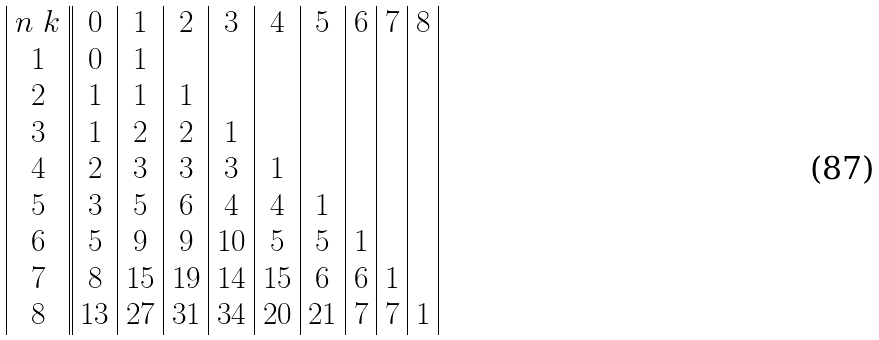<formula> <loc_0><loc_0><loc_500><loc_500>\begin{array} { | c | | c | c | c | c | c | c | c | c | c | } n \ k & 0 & 1 & 2 & 3 & 4 & 5 & 6 & 7 & 8 \\ 1 & 0 & 1 & & & & & & & \\ 2 & 1 & 1 & 1 & & & & & & \\ 3 & 1 & 2 & 2 & 1 & & & & & \\ 4 & 2 & 3 & 3 & 3 & 1 & & & & \\ 5 & 3 & 5 & 6 & 4 & 4 & 1 & & & \\ 6 & 5 & 9 & 9 & 1 0 & 5 & 5 & 1 & & \\ 7 & 8 & 1 5 & 1 9 & 1 4 & 1 5 & 6 & 6 & 1 & \\ 8 & 1 3 & 2 7 & 3 1 & 3 4 & 2 0 & 2 1 & 7 & 7 & 1 \\ \end{array}</formula> 